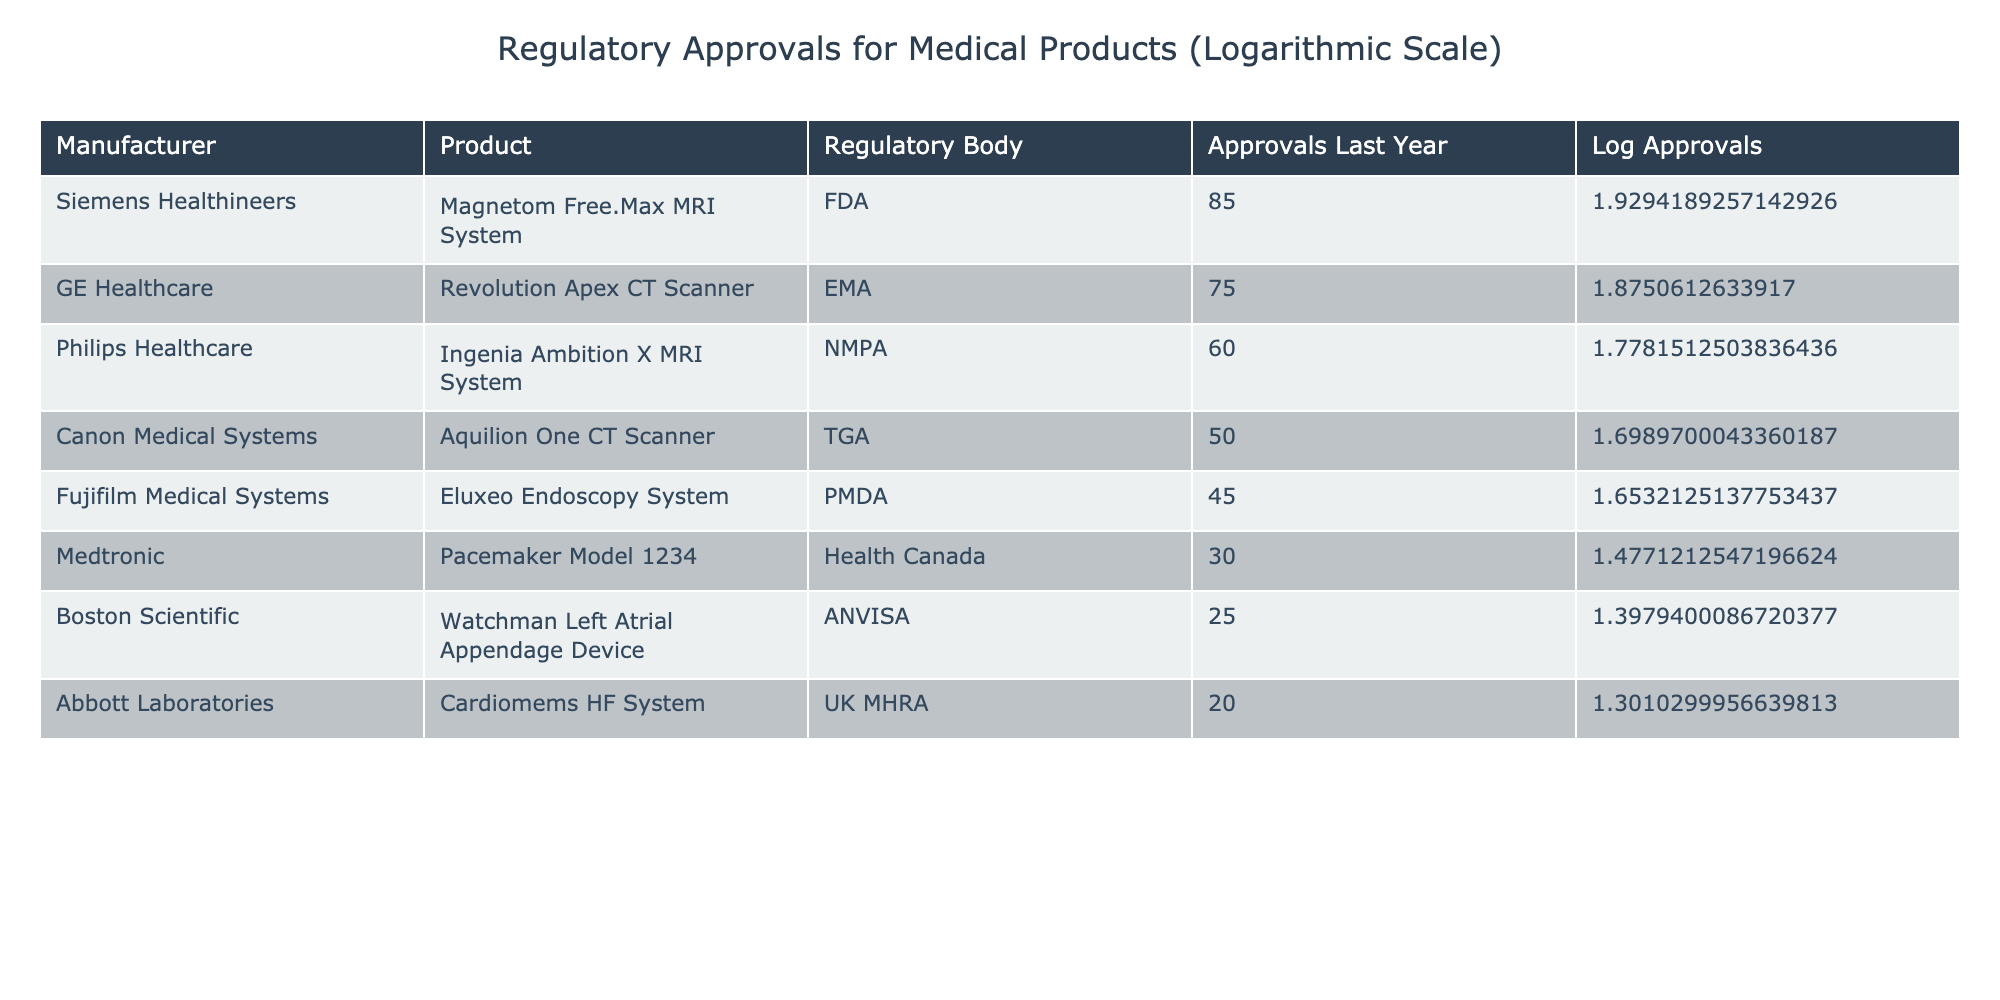What is the highest number of regulatory approvals received by a single manufacturer? The highest number of approvals can be found by scanning the "Approvals Last Year" column for the maximum value. In this case, Siemens Healthineers received 85 approvals, which is greater than all other manufacturers listed.
Answer: 85 Which regulatory body granted the most approvals to medical products? To determine this, we need to count the total approvals for each regulatory body. By checking each entry, we find that FDA had the highest with 85 approvals. All other bodies had lower totals when summed up.
Answer: FDA What is the total number of approvals received by the manufacturers listed? We need to add up all the values in the "Approvals Last Year" column. This total is calculated as follows: 85 + 75 + 60 + 50 + 45 + 30 + 25 + 20 = 390. Therefore, the total sum of approvals from all manufacturers is 390.
Answer: 390 Did any manufacturers receive less than 30 approvals last year? By looking at the "Approvals Last Year" column, we can see that both Boston Scientific (25 approvals) and Abbott Laboratories (20 approvals) fall below 30, thus confirming that there are indeed manufacturers with less than 30 approvals.
Answer: Yes What is the difference in approvals between the highest and lowest receiving manufacturers? From the table, the highest approvals are from Siemens Healthineers with 85, and the lowest are from Abbott Laboratories with 20. The difference is calculated by subtracting the lowest from the highest: 85 - 20 = 65.
Answer: 65 What is the average number of regulatory approvals received by the manufacturers in the table? To find the average, we first sum the total approvals (which is 390 as we calculated earlier) and then divide by the number of manufacturers, which is 8. The average is 390 / 8 = 48.75. Therefore, the average number of approvals is 48.75.
Answer: 48.75 Is there a manufacturer that received exactly 45 approvals? Checking the "Approvals Last Year" column shows that Fujifilm Medical Systems is the only manufacturer listed with exactly 45 approvals last year.
Answer: Yes Which manufacturer had the lowest number of approvals and what was it? To find the lowest number of approvals, we examine the "Approvals Last Year" column. The lowest value is from Abbott Laboratories with 20 approvals, making it the manufacturer with the least approvals.
Answer: Abbott Laboratories, 20 